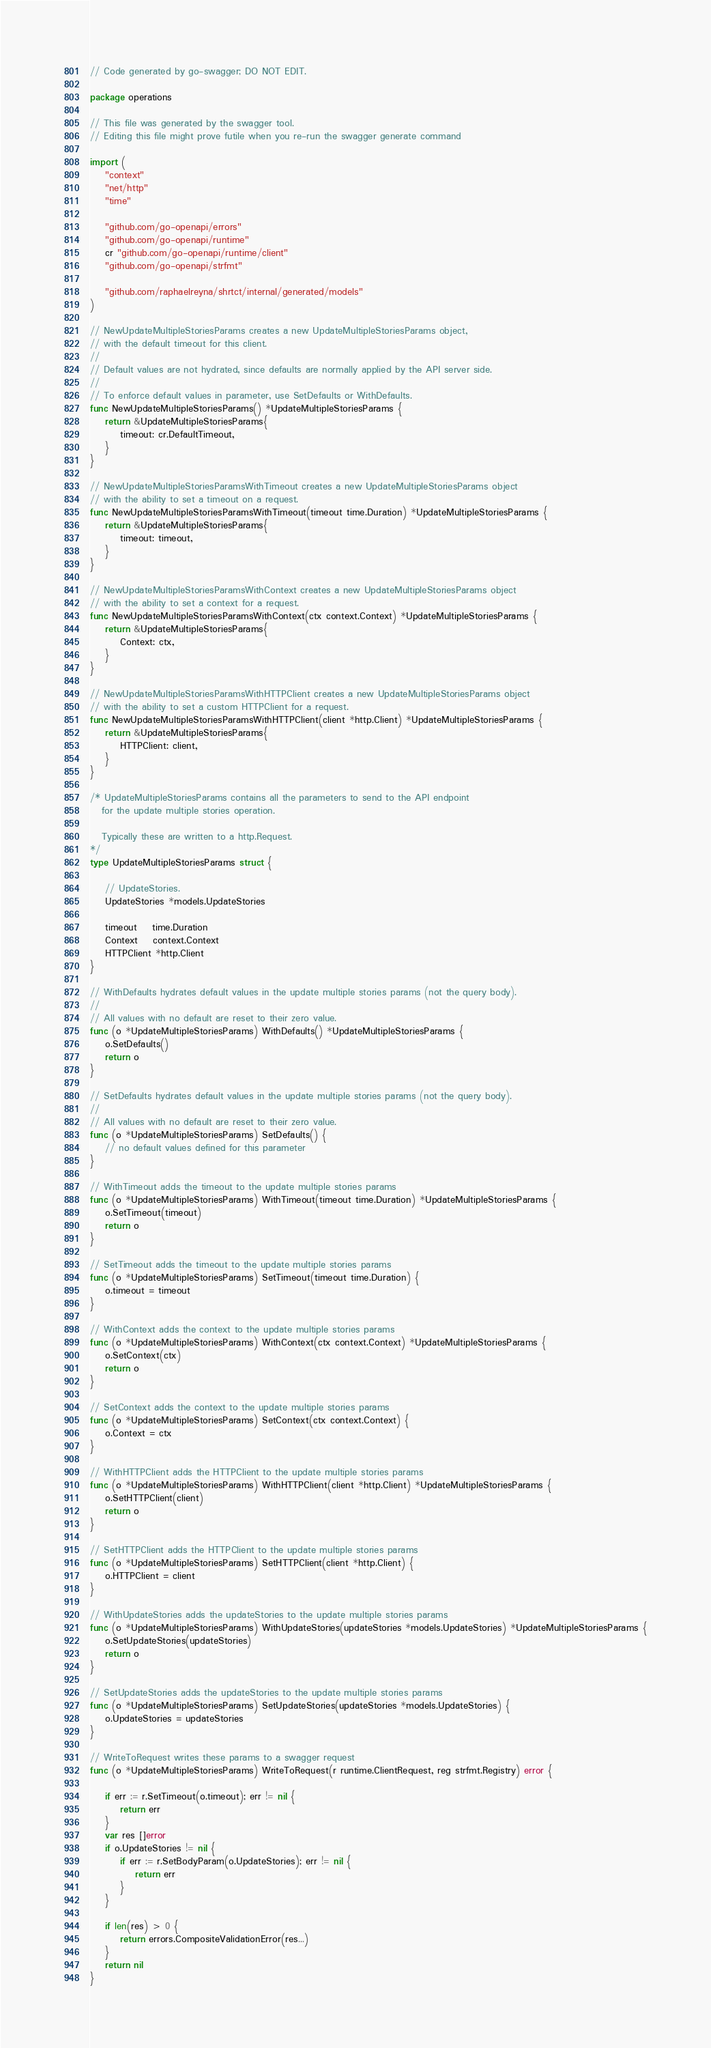Convert code to text. <code><loc_0><loc_0><loc_500><loc_500><_Go_>// Code generated by go-swagger; DO NOT EDIT.

package operations

// This file was generated by the swagger tool.
// Editing this file might prove futile when you re-run the swagger generate command

import (
	"context"
	"net/http"
	"time"

	"github.com/go-openapi/errors"
	"github.com/go-openapi/runtime"
	cr "github.com/go-openapi/runtime/client"
	"github.com/go-openapi/strfmt"

	"github.com/raphaelreyna/shrtct/internal/generated/models"
)

// NewUpdateMultipleStoriesParams creates a new UpdateMultipleStoriesParams object,
// with the default timeout for this client.
//
// Default values are not hydrated, since defaults are normally applied by the API server side.
//
// To enforce default values in parameter, use SetDefaults or WithDefaults.
func NewUpdateMultipleStoriesParams() *UpdateMultipleStoriesParams {
	return &UpdateMultipleStoriesParams{
		timeout: cr.DefaultTimeout,
	}
}

// NewUpdateMultipleStoriesParamsWithTimeout creates a new UpdateMultipleStoriesParams object
// with the ability to set a timeout on a request.
func NewUpdateMultipleStoriesParamsWithTimeout(timeout time.Duration) *UpdateMultipleStoriesParams {
	return &UpdateMultipleStoriesParams{
		timeout: timeout,
	}
}

// NewUpdateMultipleStoriesParamsWithContext creates a new UpdateMultipleStoriesParams object
// with the ability to set a context for a request.
func NewUpdateMultipleStoriesParamsWithContext(ctx context.Context) *UpdateMultipleStoriesParams {
	return &UpdateMultipleStoriesParams{
		Context: ctx,
	}
}

// NewUpdateMultipleStoriesParamsWithHTTPClient creates a new UpdateMultipleStoriesParams object
// with the ability to set a custom HTTPClient for a request.
func NewUpdateMultipleStoriesParamsWithHTTPClient(client *http.Client) *UpdateMultipleStoriesParams {
	return &UpdateMultipleStoriesParams{
		HTTPClient: client,
	}
}

/* UpdateMultipleStoriesParams contains all the parameters to send to the API endpoint
   for the update multiple stories operation.

   Typically these are written to a http.Request.
*/
type UpdateMultipleStoriesParams struct {

	// UpdateStories.
	UpdateStories *models.UpdateStories

	timeout    time.Duration
	Context    context.Context
	HTTPClient *http.Client
}

// WithDefaults hydrates default values in the update multiple stories params (not the query body).
//
// All values with no default are reset to their zero value.
func (o *UpdateMultipleStoriesParams) WithDefaults() *UpdateMultipleStoriesParams {
	o.SetDefaults()
	return o
}

// SetDefaults hydrates default values in the update multiple stories params (not the query body).
//
// All values with no default are reset to their zero value.
func (o *UpdateMultipleStoriesParams) SetDefaults() {
	// no default values defined for this parameter
}

// WithTimeout adds the timeout to the update multiple stories params
func (o *UpdateMultipleStoriesParams) WithTimeout(timeout time.Duration) *UpdateMultipleStoriesParams {
	o.SetTimeout(timeout)
	return o
}

// SetTimeout adds the timeout to the update multiple stories params
func (o *UpdateMultipleStoriesParams) SetTimeout(timeout time.Duration) {
	o.timeout = timeout
}

// WithContext adds the context to the update multiple stories params
func (o *UpdateMultipleStoriesParams) WithContext(ctx context.Context) *UpdateMultipleStoriesParams {
	o.SetContext(ctx)
	return o
}

// SetContext adds the context to the update multiple stories params
func (o *UpdateMultipleStoriesParams) SetContext(ctx context.Context) {
	o.Context = ctx
}

// WithHTTPClient adds the HTTPClient to the update multiple stories params
func (o *UpdateMultipleStoriesParams) WithHTTPClient(client *http.Client) *UpdateMultipleStoriesParams {
	o.SetHTTPClient(client)
	return o
}

// SetHTTPClient adds the HTTPClient to the update multiple stories params
func (o *UpdateMultipleStoriesParams) SetHTTPClient(client *http.Client) {
	o.HTTPClient = client
}

// WithUpdateStories adds the updateStories to the update multiple stories params
func (o *UpdateMultipleStoriesParams) WithUpdateStories(updateStories *models.UpdateStories) *UpdateMultipleStoriesParams {
	o.SetUpdateStories(updateStories)
	return o
}

// SetUpdateStories adds the updateStories to the update multiple stories params
func (o *UpdateMultipleStoriesParams) SetUpdateStories(updateStories *models.UpdateStories) {
	o.UpdateStories = updateStories
}

// WriteToRequest writes these params to a swagger request
func (o *UpdateMultipleStoriesParams) WriteToRequest(r runtime.ClientRequest, reg strfmt.Registry) error {

	if err := r.SetTimeout(o.timeout); err != nil {
		return err
	}
	var res []error
	if o.UpdateStories != nil {
		if err := r.SetBodyParam(o.UpdateStories); err != nil {
			return err
		}
	}

	if len(res) > 0 {
		return errors.CompositeValidationError(res...)
	}
	return nil
}
</code> 